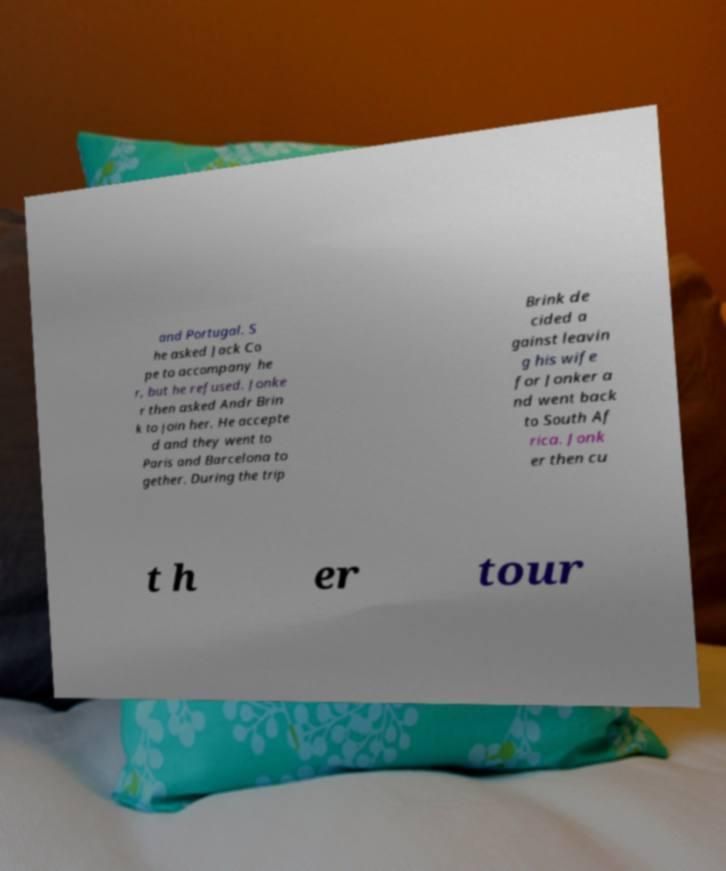Could you assist in decoding the text presented in this image and type it out clearly? and Portugal. S he asked Jack Co pe to accompany he r, but he refused. Jonke r then asked Andr Brin k to join her. He accepte d and they went to Paris and Barcelona to gether. During the trip Brink de cided a gainst leavin g his wife for Jonker a nd went back to South Af rica. Jonk er then cu t h er tour 